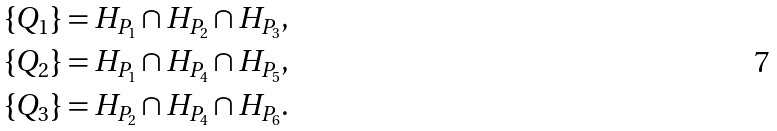Convert formula to latex. <formula><loc_0><loc_0><loc_500><loc_500>\{ Q _ { 1 } \} & = H _ { P _ { 1 } } \cap H _ { P _ { 2 } } \cap H _ { P _ { 3 } } , \\ \{ Q _ { 2 } \} & = H _ { P _ { 1 } } \cap H _ { P _ { 4 } } \cap H _ { P _ { 5 } } , \\ \{ Q _ { 3 } \} & = H _ { P _ { 2 } } \cap H _ { P _ { 4 } } \cap H _ { P _ { 6 } } .</formula> 